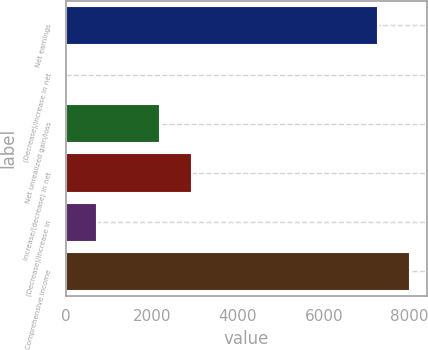Convert chart to OTSL. <chart><loc_0><loc_0><loc_500><loc_500><bar_chart><fcel>Net earnings<fcel>(Decrease)/increase in net<fcel>Net unrealized gain/loss<fcel>Increase/(decrease) in net<fcel>(Decrease)/increase in<fcel>Comprehensive income<nl><fcel>7264<fcel>2<fcel>2202.5<fcel>2936<fcel>735.5<fcel>7997.5<nl></chart> 